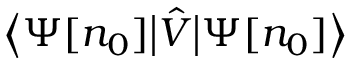Convert formula to latex. <formula><loc_0><loc_0><loc_500><loc_500>{ \left \langle } \Psi [ n _ { 0 } ] { \left | } { \hat { V } } { \right | } \Psi [ n _ { 0 } ] { \right \rangle }</formula> 